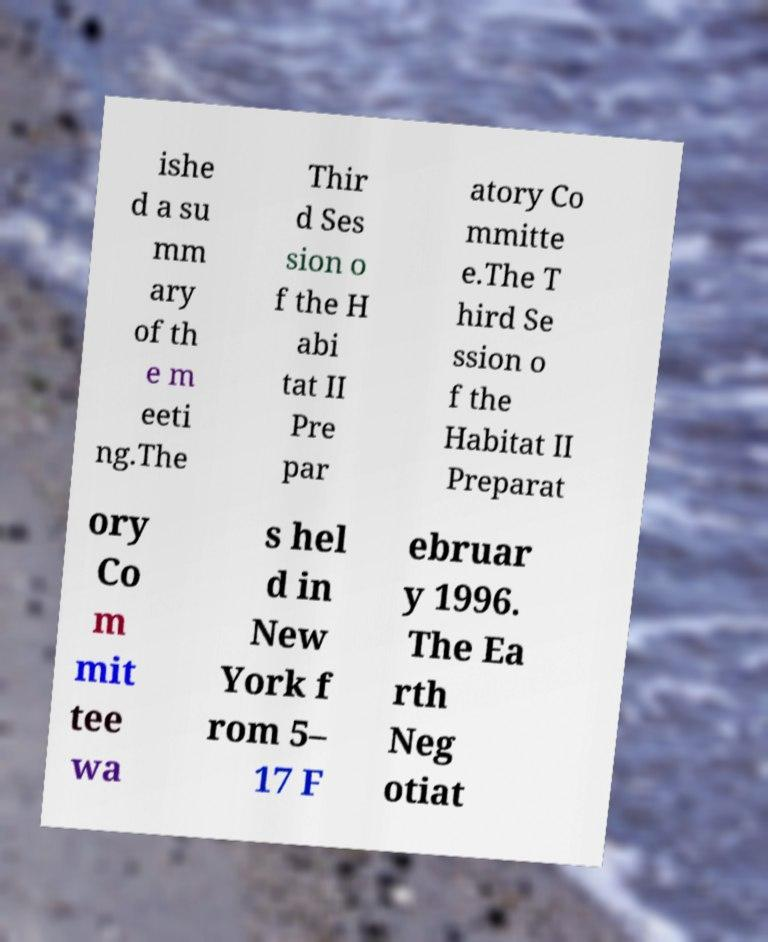Can you read and provide the text displayed in the image?This photo seems to have some interesting text. Can you extract and type it out for me? ishe d a su mm ary of th e m eeti ng.The Thir d Ses sion o f the H abi tat II Pre par atory Co mmitte e.The T hird Se ssion o f the Habitat II Preparat ory Co m mit tee wa s hel d in New York f rom 5– 17 F ebruar y 1996. The Ea rth Neg otiat 